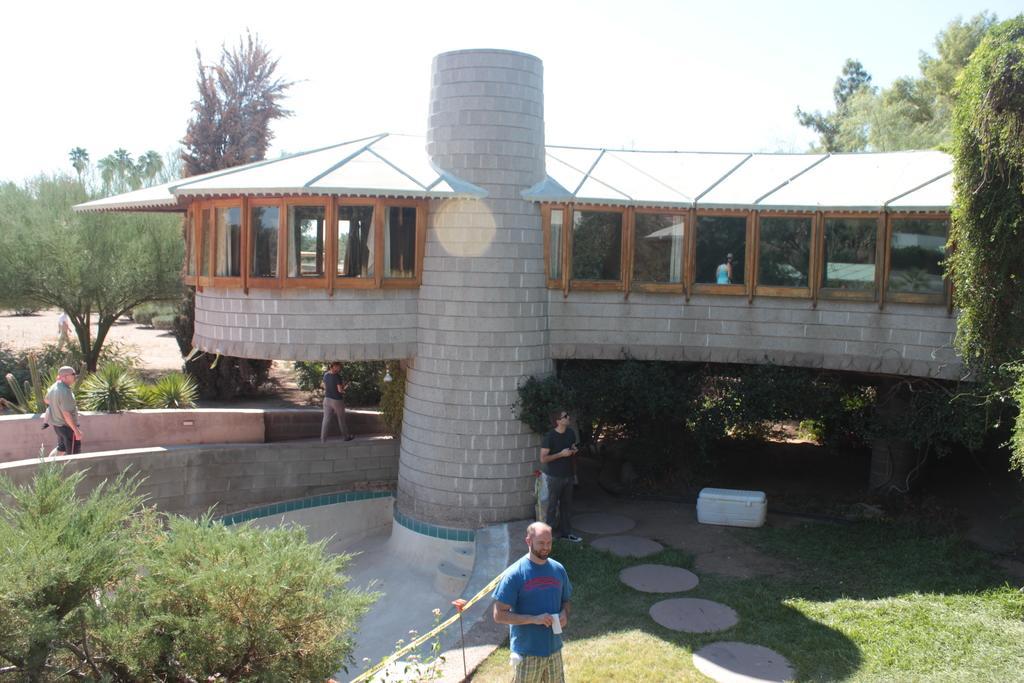How would you summarize this image in a sentence or two? In the foreground of this image, at the bottom, there is a man standing and holding an object. In the middle, there is a building, trees and a tree at the bottom, three people standing and walking, grassland, swimming pool and the barrier tape. In the background, there are trees, a person walking and the sky. 